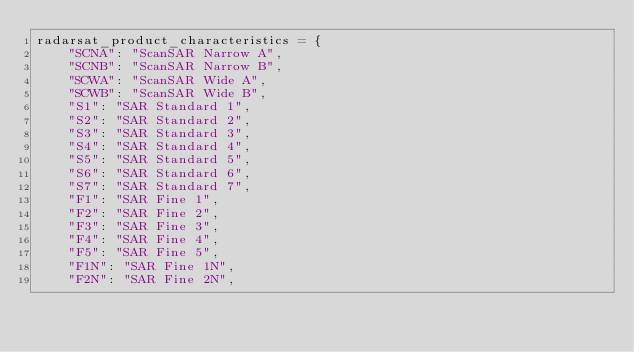Convert code to text. <code><loc_0><loc_0><loc_500><loc_500><_Python_>radarsat_product_characteristics = {
    "SCNA": "ScanSAR Narrow A",
    "SCNB": "ScanSAR Narrow B",
    "SCWA": "ScanSAR Wide A",
    "SCWB": "ScanSAR Wide B",
    "S1": "SAR Standard 1",
    "S2": "SAR Standard 2",
    "S3": "SAR Standard 3",
    "S4": "SAR Standard 4",
    "S5": "SAR Standard 5",
    "S6": "SAR Standard 6",
    "S7": "SAR Standard 7",
    "F1": "SAR Fine 1",
    "F2": "SAR Fine 2",
    "F3": "SAR Fine 3",
    "F4": "SAR Fine 4",
    "F5": "SAR Fine 5",
    "F1N": "SAR Fine 1N",
    "F2N": "SAR Fine 2N",</code> 